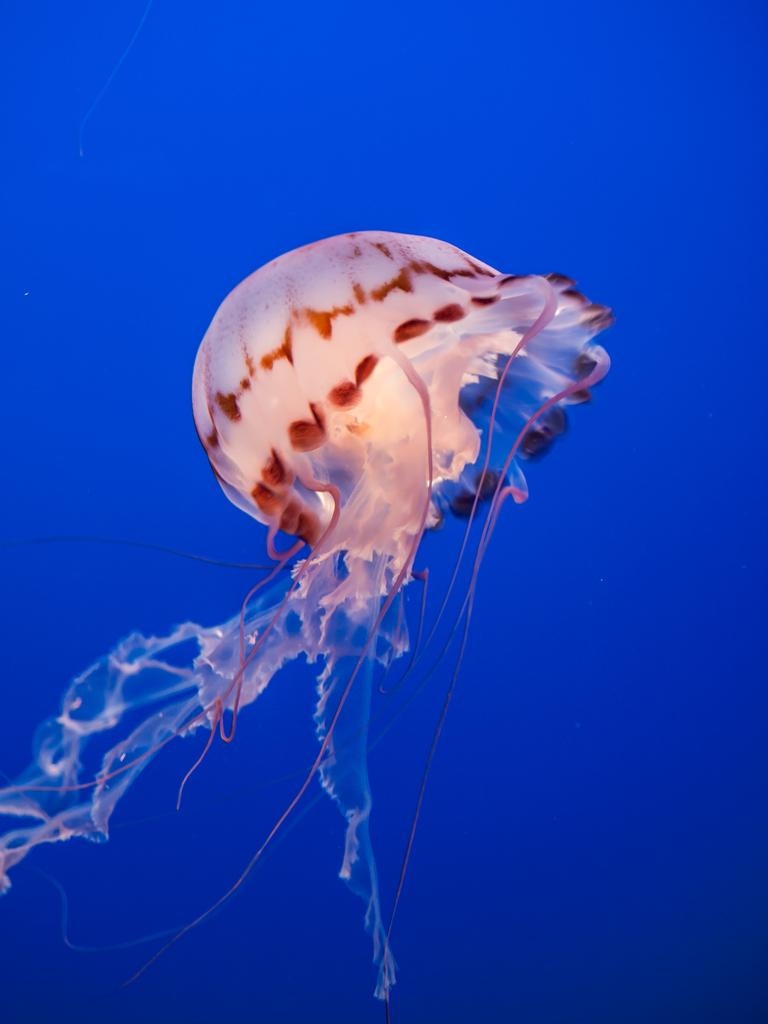What type of animal is in the image? There is a fish in the image. What color is the fish? The fish is white in color. What can be seen in the background of the image? There is water in the background of the image. What color is the water? The water is blue in color. Can you see a squirrel climbing a tree in the image? There is no squirrel or tree present in the image; it features a white fish in water. 